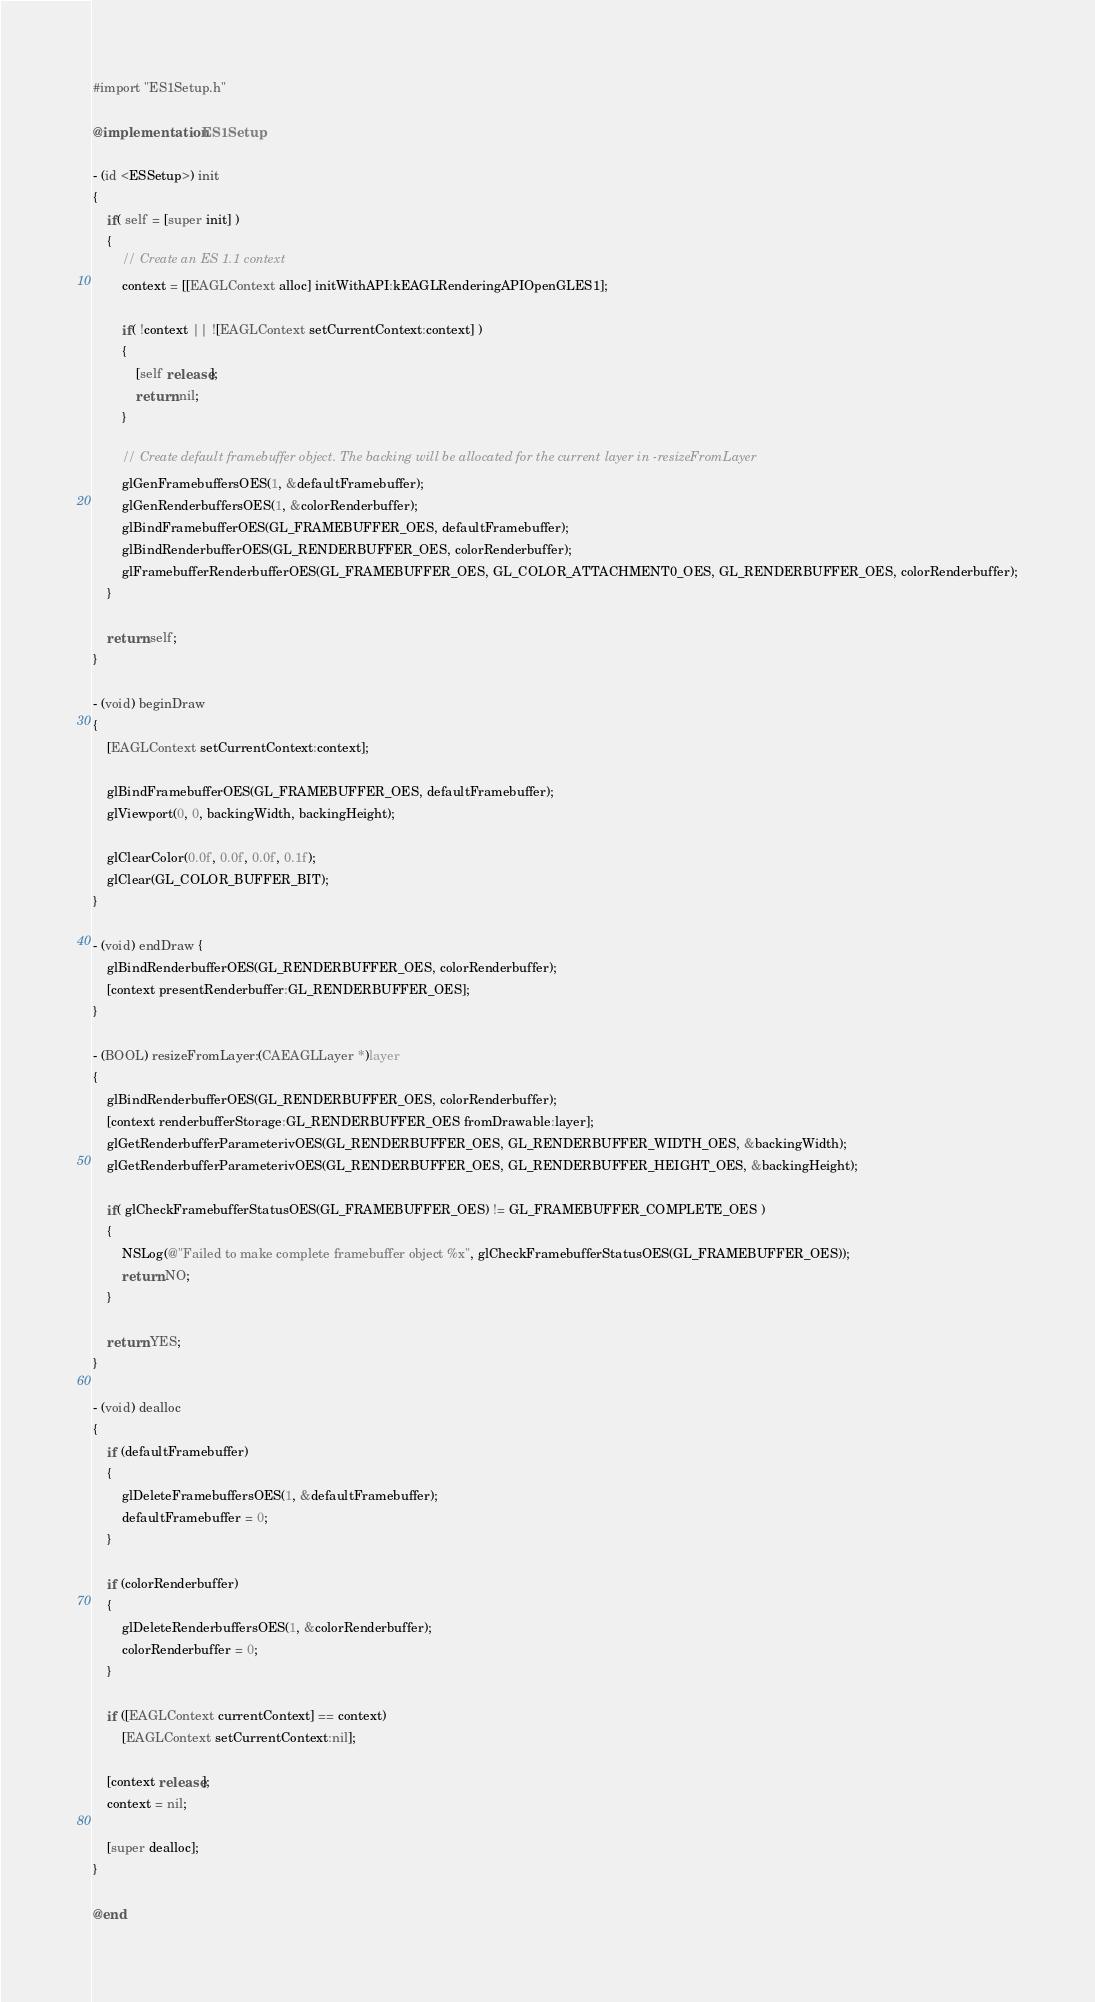Convert code to text. <code><loc_0><loc_0><loc_500><loc_500><_ObjectiveC_>
#import "ES1Setup.h"

@implementation ES1Setup

- (id <ESSetup>) init
{
	if( self = [super init] )
	{
		// Create an ES 1.1 context
		context = [[EAGLContext alloc] initWithAPI:kEAGLRenderingAPIOpenGLES1];
        
        if( !context || ![EAGLContext setCurrentContext:context] )
		{
            [self release];
            return nil;
        }
		
		// Create default framebuffer object. The backing will be allocated for the current layer in -resizeFromLayer
		glGenFramebuffersOES(1, &defaultFramebuffer);
		glGenRenderbuffersOES(1, &colorRenderbuffer);
		glBindFramebufferOES(GL_FRAMEBUFFER_OES, defaultFramebuffer);
		glBindRenderbufferOES(GL_RENDERBUFFER_OES, colorRenderbuffer);
		glFramebufferRenderbufferOES(GL_FRAMEBUFFER_OES, GL_COLOR_ATTACHMENT0_OES, GL_RENDERBUFFER_OES, colorRenderbuffer);
	}
	
	return self;
}

- (void) beginDraw
{
	[EAGLContext setCurrentContext:context];
    
    glBindFramebufferOES(GL_FRAMEBUFFER_OES, defaultFramebuffer);
    glViewport(0, 0, backingWidth, backingHeight);
	
    glClearColor(0.0f, 0.0f, 0.0f, 0.1f);
    glClear(GL_COLOR_BUFFER_BIT);
}

- (void) endDraw {
	glBindRenderbufferOES(GL_RENDERBUFFER_OES, colorRenderbuffer);
    [context presentRenderbuffer:GL_RENDERBUFFER_OES];	
}

- (BOOL) resizeFromLayer:(CAEAGLLayer *)layer
{
    glBindRenderbufferOES(GL_RENDERBUFFER_OES, colorRenderbuffer);
    [context renderbufferStorage:GL_RENDERBUFFER_OES fromDrawable:layer];
	glGetRenderbufferParameterivOES(GL_RENDERBUFFER_OES, GL_RENDERBUFFER_WIDTH_OES, &backingWidth);
    glGetRenderbufferParameterivOES(GL_RENDERBUFFER_OES, GL_RENDERBUFFER_HEIGHT_OES, &backingHeight);
	
    if( glCheckFramebufferStatusOES(GL_FRAMEBUFFER_OES) != GL_FRAMEBUFFER_COMPLETE_OES )
	{
		NSLog(@"Failed to make complete framebuffer object %x", glCheckFramebufferStatusOES(GL_FRAMEBUFFER_OES));
        return NO;
    }
    
    return YES;
}

- (void) dealloc
{
	if (defaultFramebuffer)
	{
		glDeleteFramebuffersOES(1, &defaultFramebuffer);
		defaultFramebuffer = 0;
	}
	
	if (colorRenderbuffer)
	{
		glDeleteRenderbuffersOES(1, &colorRenderbuffer);
		colorRenderbuffer = 0;
	}
	
	if ([EAGLContext currentContext] == context)
        [EAGLContext setCurrentContext:nil];
	
	[context release];
	context = nil;
	
	[super dealloc];
}

@end
</code> 